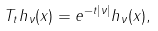Convert formula to latex. <formula><loc_0><loc_0><loc_500><loc_500>T _ { t } h _ { \nu } ( x ) = e ^ { - t \left | \nu \right | } h _ { \nu } ( x ) ,</formula> 